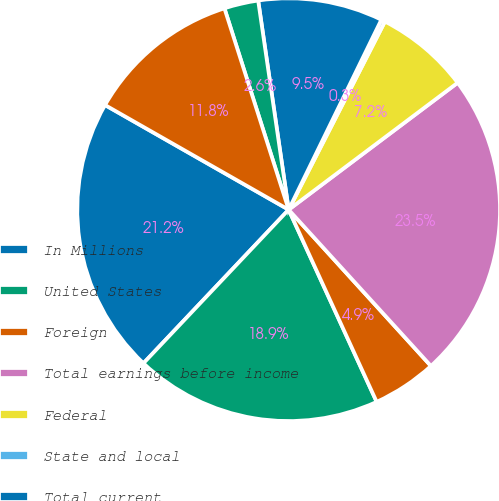Convert chart. <chart><loc_0><loc_0><loc_500><loc_500><pie_chart><fcel>In Millions<fcel>United States<fcel>Foreign<fcel>Total earnings before income<fcel>Federal<fcel>State and local<fcel>Total current<fcel>Total deferred<fcel>Total income taxes<nl><fcel>21.19%<fcel>18.89%<fcel>4.92%<fcel>23.5%<fcel>7.22%<fcel>0.3%<fcel>9.53%<fcel>2.61%<fcel>11.84%<nl></chart> 